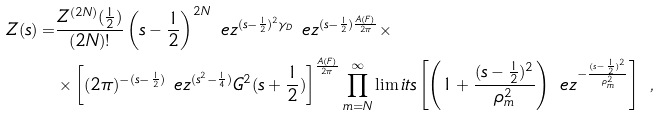Convert formula to latex. <formula><loc_0><loc_0><loc_500><loc_500>Z ( s ) = & \frac { Z ^ { ( 2 N ) } ( \frac { 1 } { 2 } ) } { ( 2 N ) ! } \left ( s - \frac { 1 } { 2 } \right ) ^ { 2 N } \ e z ^ { ( s - \frac { 1 } { 2 } ) ^ { 2 } \gamma _ { D } } \ e z ^ { ( s - \frac { 1 } { 2 } ) \frac { A ( F ) } { 2 \pi } } \times \\ & \times \left [ ( 2 \pi ) ^ { - ( s - \frac { 1 } { 2 } ) } \ e z ^ { ( s ^ { 2 } - \frac { 1 } { 4 } ) } G ^ { 2 } ( s + \frac { 1 } { 2 } ) \right ] ^ { \frac { A ( F ) } { 2 \pi } } \prod _ { m = N } ^ { \infty } \lim i t s \left [ \left ( 1 + \frac { ( s - \frac { 1 } { 2 } ) ^ { 2 } } { \rho _ { m } ^ { 2 } } \right ) \ e z ^ { - \frac { ( s - \frac { 1 } { 2 } ) ^ { 2 } } { \rho _ { m } ^ { 2 } } } \right ] \ ,</formula> 